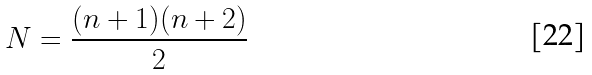Convert formula to latex. <formula><loc_0><loc_0><loc_500><loc_500>N = \frac { ( n + 1 ) ( n + 2 ) } { 2 }</formula> 